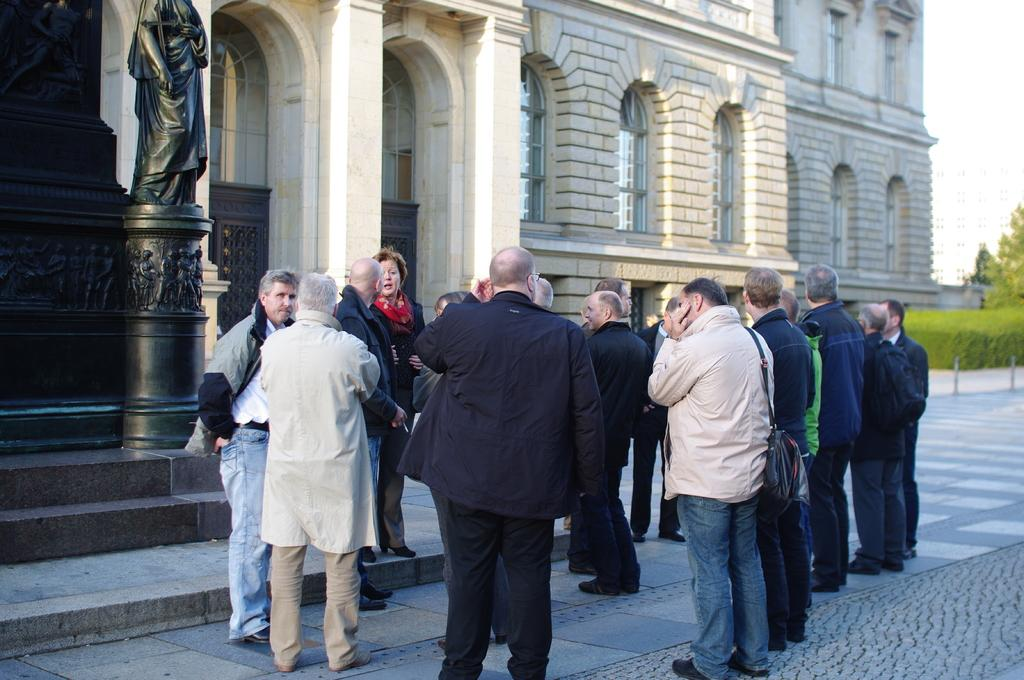What can be seen on the floor in the image? There are people standing on the floor in the image. What type of structure is present in the image? There is a building in the image. What is the statue in the image made of? The provided facts do not specify the material of the statue. What architectural features can be seen in the image? There are windows in the image. What type of vegetation is present in the image? There are plants and trees in the image. What is visible in the sky in the image? The sky is visible in the image. What type of coal is being used to start a fire in the image? There is no coal or fire present in the image. Can you describe the person standing next to the statue in the image? The provided facts do not mention any specific person standing next to the statue. 